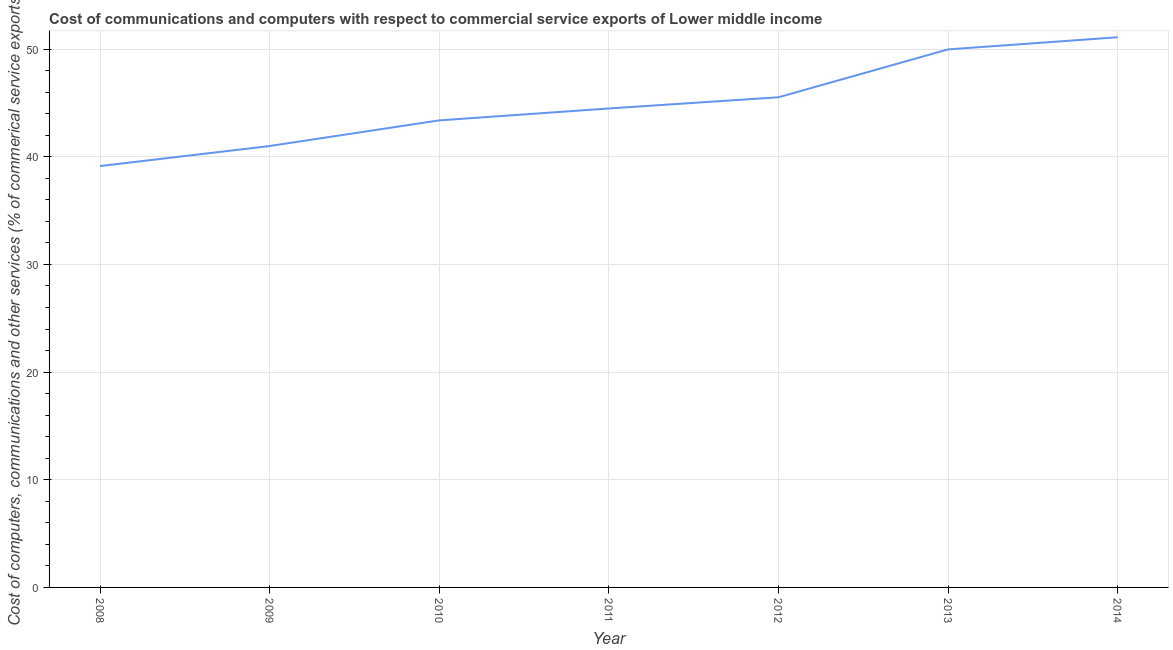What is the  computer and other services in 2012?
Offer a terse response. 45.53. Across all years, what is the maximum cost of communications?
Keep it short and to the point. 51.1. Across all years, what is the minimum cost of communications?
Keep it short and to the point. 39.14. In which year was the  computer and other services maximum?
Provide a succinct answer. 2014. In which year was the  computer and other services minimum?
Give a very brief answer. 2008. What is the sum of the cost of communications?
Your answer should be very brief. 314.6. What is the difference between the  computer and other services in 2008 and 2014?
Provide a succinct answer. -11.96. What is the average  computer and other services per year?
Your answer should be compact. 44.94. What is the median cost of communications?
Make the answer very short. 44.49. What is the ratio of the  computer and other services in 2011 to that in 2012?
Your answer should be very brief. 0.98. Is the difference between the cost of communications in 2009 and 2012 greater than the difference between any two years?
Your answer should be very brief. No. What is the difference between the highest and the second highest cost of communications?
Keep it short and to the point. 1.13. Is the sum of the  computer and other services in 2010 and 2012 greater than the maximum  computer and other services across all years?
Your response must be concise. Yes. What is the difference between the highest and the lowest  computer and other services?
Your response must be concise. 11.96. In how many years, is the cost of communications greater than the average cost of communications taken over all years?
Keep it short and to the point. 3. How many lines are there?
Ensure brevity in your answer.  1. Does the graph contain grids?
Your response must be concise. Yes. What is the title of the graph?
Provide a short and direct response. Cost of communications and computers with respect to commercial service exports of Lower middle income. What is the label or title of the X-axis?
Make the answer very short. Year. What is the label or title of the Y-axis?
Your answer should be compact. Cost of computers, communications and other services (% of commerical service exports). What is the Cost of computers, communications and other services (% of commerical service exports) in 2008?
Provide a short and direct response. 39.14. What is the Cost of computers, communications and other services (% of commerical service exports) in 2009?
Your answer should be very brief. 41. What is the Cost of computers, communications and other services (% of commerical service exports) of 2010?
Make the answer very short. 43.38. What is the Cost of computers, communications and other services (% of commerical service exports) of 2011?
Offer a very short reply. 44.49. What is the Cost of computers, communications and other services (% of commerical service exports) of 2012?
Your answer should be very brief. 45.53. What is the Cost of computers, communications and other services (% of commerical service exports) in 2013?
Provide a short and direct response. 49.97. What is the Cost of computers, communications and other services (% of commerical service exports) of 2014?
Keep it short and to the point. 51.1. What is the difference between the Cost of computers, communications and other services (% of commerical service exports) in 2008 and 2009?
Offer a terse response. -1.86. What is the difference between the Cost of computers, communications and other services (% of commerical service exports) in 2008 and 2010?
Give a very brief answer. -4.24. What is the difference between the Cost of computers, communications and other services (% of commerical service exports) in 2008 and 2011?
Ensure brevity in your answer.  -5.35. What is the difference between the Cost of computers, communications and other services (% of commerical service exports) in 2008 and 2012?
Your response must be concise. -6.39. What is the difference between the Cost of computers, communications and other services (% of commerical service exports) in 2008 and 2013?
Give a very brief answer. -10.84. What is the difference between the Cost of computers, communications and other services (% of commerical service exports) in 2008 and 2014?
Provide a succinct answer. -11.96. What is the difference between the Cost of computers, communications and other services (% of commerical service exports) in 2009 and 2010?
Your answer should be very brief. -2.38. What is the difference between the Cost of computers, communications and other services (% of commerical service exports) in 2009 and 2011?
Make the answer very short. -3.49. What is the difference between the Cost of computers, communications and other services (% of commerical service exports) in 2009 and 2012?
Your response must be concise. -4.53. What is the difference between the Cost of computers, communications and other services (% of commerical service exports) in 2009 and 2013?
Your answer should be compact. -8.97. What is the difference between the Cost of computers, communications and other services (% of commerical service exports) in 2009 and 2014?
Your response must be concise. -10.1. What is the difference between the Cost of computers, communications and other services (% of commerical service exports) in 2010 and 2011?
Provide a succinct answer. -1.11. What is the difference between the Cost of computers, communications and other services (% of commerical service exports) in 2010 and 2012?
Offer a very short reply. -2.14. What is the difference between the Cost of computers, communications and other services (% of commerical service exports) in 2010 and 2013?
Provide a short and direct response. -6.59. What is the difference between the Cost of computers, communications and other services (% of commerical service exports) in 2010 and 2014?
Your response must be concise. -7.72. What is the difference between the Cost of computers, communications and other services (% of commerical service exports) in 2011 and 2012?
Offer a very short reply. -1.04. What is the difference between the Cost of computers, communications and other services (% of commerical service exports) in 2011 and 2013?
Provide a succinct answer. -5.49. What is the difference between the Cost of computers, communications and other services (% of commerical service exports) in 2011 and 2014?
Your answer should be very brief. -6.61. What is the difference between the Cost of computers, communications and other services (% of commerical service exports) in 2012 and 2013?
Provide a succinct answer. -4.45. What is the difference between the Cost of computers, communications and other services (% of commerical service exports) in 2012 and 2014?
Provide a succinct answer. -5.58. What is the difference between the Cost of computers, communications and other services (% of commerical service exports) in 2013 and 2014?
Keep it short and to the point. -1.13. What is the ratio of the Cost of computers, communications and other services (% of commerical service exports) in 2008 to that in 2009?
Your answer should be very brief. 0.95. What is the ratio of the Cost of computers, communications and other services (% of commerical service exports) in 2008 to that in 2010?
Your answer should be compact. 0.9. What is the ratio of the Cost of computers, communications and other services (% of commerical service exports) in 2008 to that in 2011?
Offer a very short reply. 0.88. What is the ratio of the Cost of computers, communications and other services (% of commerical service exports) in 2008 to that in 2012?
Provide a succinct answer. 0.86. What is the ratio of the Cost of computers, communications and other services (% of commerical service exports) in 2008 to that in 2013?
Provide a short and direct response. 0.78. What is the ratio of the Cost of computers, communications and other services (% of commerical service exports) in 2008 to that in 2014?
Your answer should be very brief. 0.77. What is the ratio of the Cost of computers, communications and other services (% of commerical service exports) in 2009 to that in 2010?
Ensure brevity in your answer.  0.94. What is the ratio of the Cost of computers, communications and other services (% of commerical service exports) in 2009 to that in 2011?
Provide a succinct answer. 0.92. What is the ratio of the Cost of computers, communications and other services (% of commerical service exports) in 2009 to that in 2012?
Offer a very short reply. 0.9. What is the ratio of the Cost of computers, communications and other services (% of commerical service exports) in 2009 to that in 2013?
Your answer should be very brief. 0.82. What is the ratio of the Cost of computers, communications and other services (% of commerical service exports) in 2009 to that in 2014?
Your answer should be compact. 0.8. What is the ratio of the Cost of computers, communications and other services (% of commerical service exports) in 2010 to that in 2011?
Keep it short and to the point. 0.97. What is the ratio of the Cost of computers, communications and other services (% of commerical service exports) in 2010 to that in 2012?
Your answer should be very brief. 0.95. What is the ratio of the Cost of computers, communications and other services (% of commerical service exports) in 2010 to that in 2013?
Keep it short and to the point. 0.87. What is the ratio of the Cost of computers, communications and other services (% of commerical service exports) in 2010 to that in 2014?
Your response must be concise. 0.85. What is the ratio of the Cost of computers, communications and other services (% of commerical service exports) in 2011 to that in 2013?
Give a very brief answer. 0.89. What is the ratio of the Cost of computers, communications and other services (% of commerical service exports) in 2011 to that in 2014?
Offer a very short reply. 0.87. What is the ratio of the Cost of computers, communications and other services (% of commerical service exports) in 2012 to that in 2013?
Your response must be concise. 0.91. What is the ratio of the Cost of computers, communications and other services (% of commerical service exports) in 2012 to that in 2014?
Your response must be concise. 0.89. 